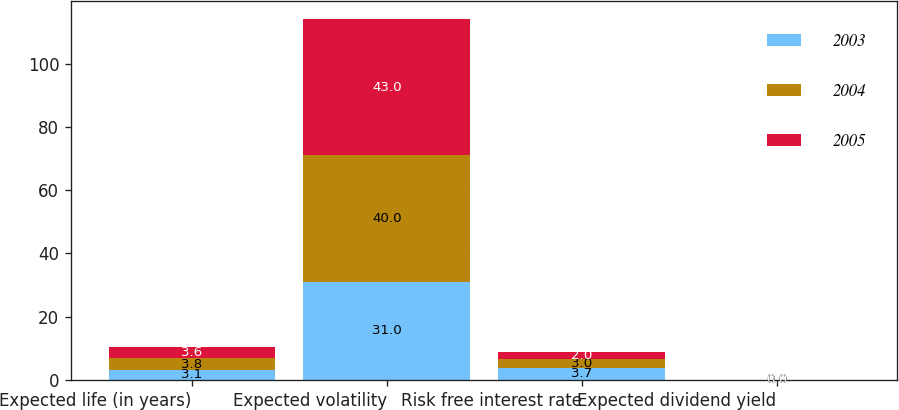Convert chart. <chart><loc_0><loc_0><loc_500><loc_500><stacked_bar_chart><ecel><fcel>Expected life (in years)<fcel>Expected volatility<fcel>Risk free interest rate<fcel>Expected dividend yield<nl><fcel>2003<fcel>3.1<fcel>31<fcel>3.7<fcel>0<nl><fcel>2004<fcel>3.8<fcel>40<fcel>3<fcel>0<nl><fcel>2005<fcel>3.6<fcel>43<fcel>2<fcel>0<nl></chart> 